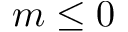<formula> <loc_0><loc_0><loc_500><loc_500>m \leq 0</formula> 